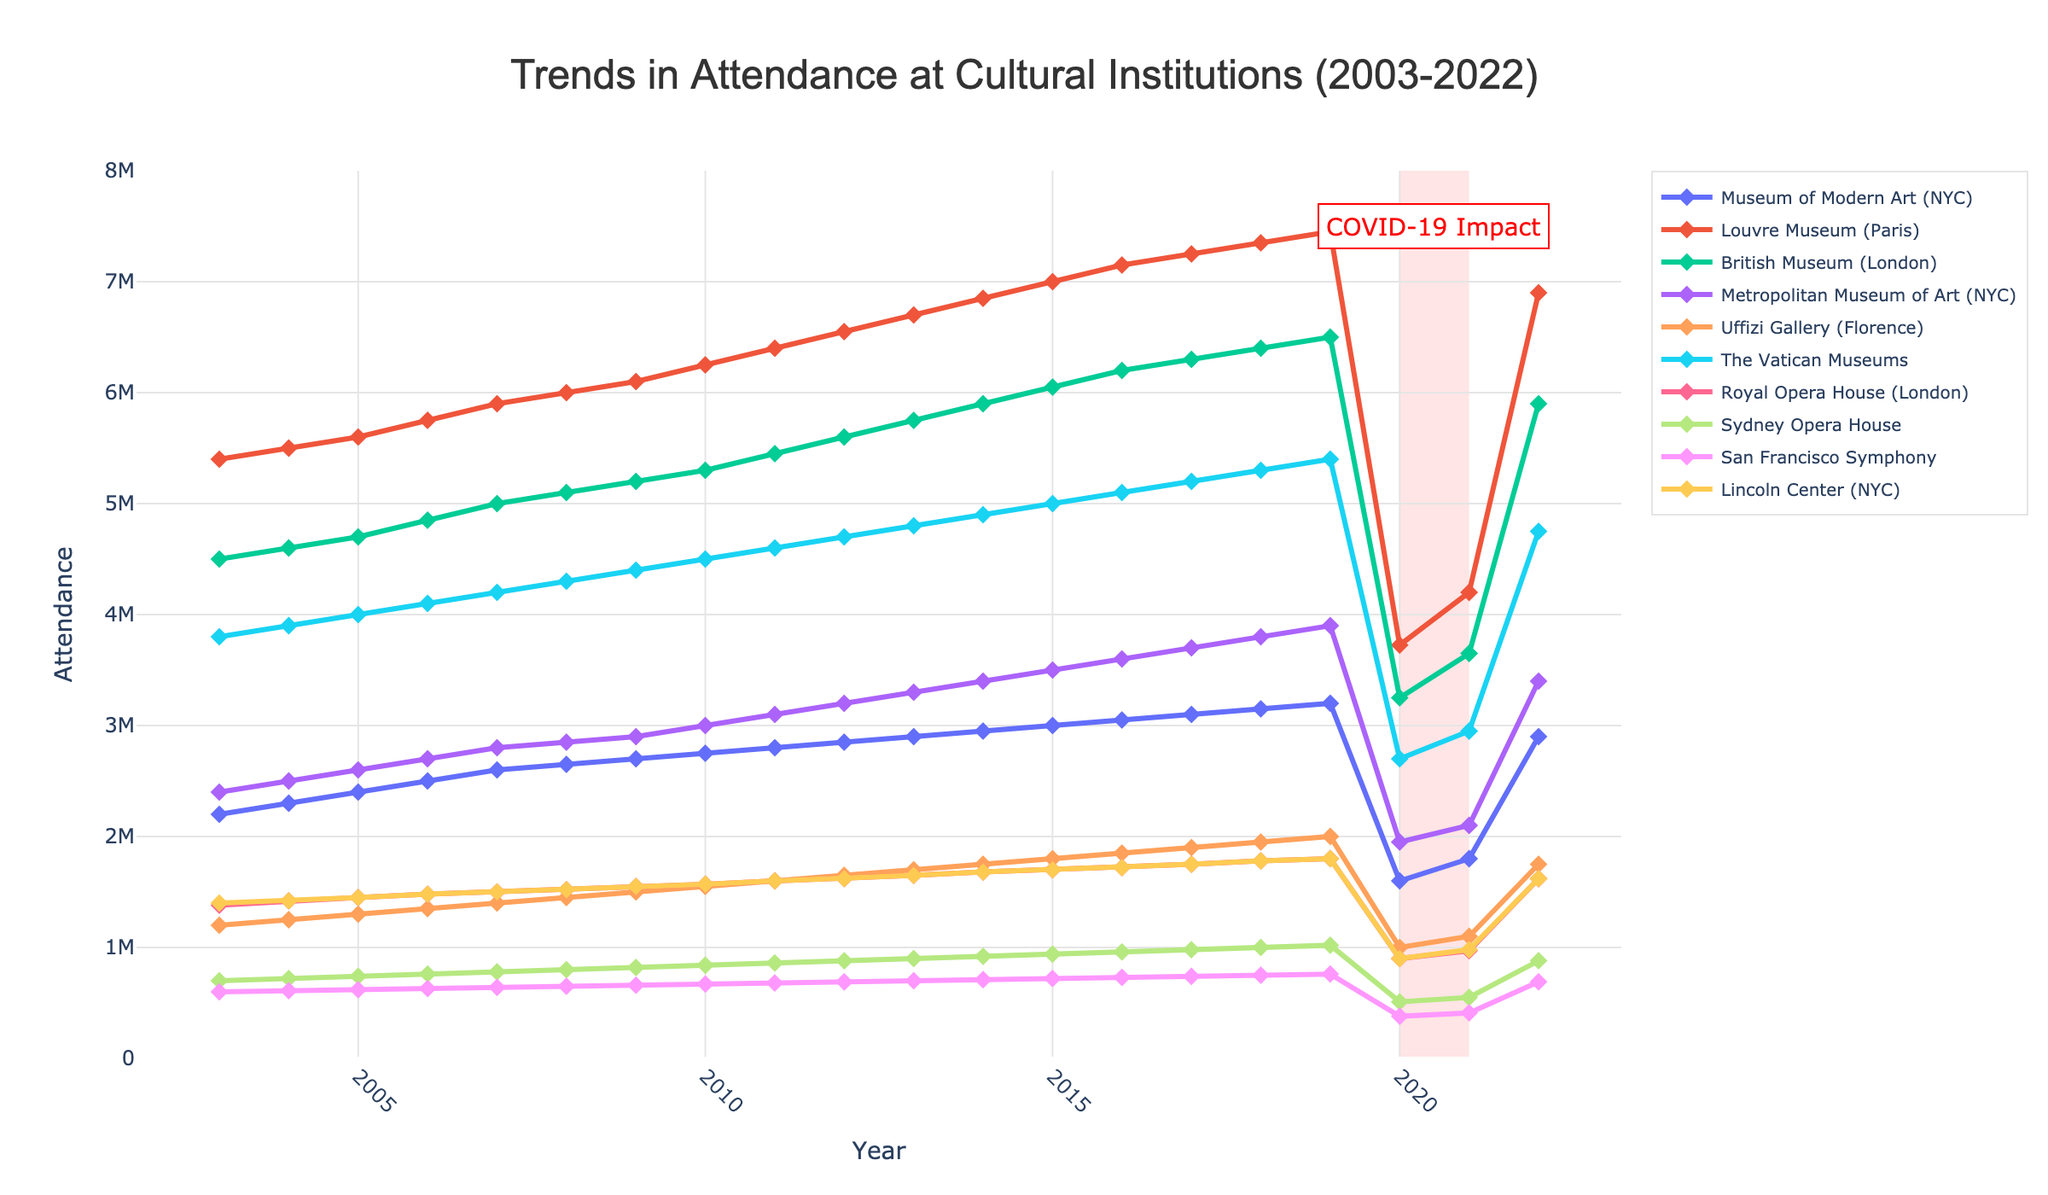What is the title of the figure? The title is usually located at the top of the figure and summarizes the main subject. According to the provided code, the title should be visible and clearly stated.
Answer: Trends in Attendance at Cultural Institutions (2003-2022) Which institution had the highest attendance in 2022? Look at the attendance values for all institutions in the year 2022 and identify the highest value. Comparing these values, the Louvre Museum (Paris) has the highest attendance.
Answer: Louvre Museum (Paris) What is the range of attendance for the Metropolitan Museum of Art (NYC) from 2003 to 2022? Identify the maximum and minimum attendance values for the Metropolitan Museum of Art (NYC) over the years 2003 to 2022. The maximum is 3900000 in 2019, and the minimum is 1950000 in 2020 due to COVID-19 impact.
Answer: 1950000 to 3900000 How did the attendance at the Sydney Opera House change during the COVID-19 period (2020-2021)? Look at the attendance values for the Sydney Opera House in the years 2020 and 2021. Determine if there was an increase, decrease, or no change. The attendance was 510000 in 2020 and 550000 in 2021.
Answer: It increased Between which years did the British Museum (London) see the largest increase in attendance? Calculate the year-to-year differences in attendance for the British Museum (London) from 2003 to 2022 and identify the largest increase. The largest increase is between 2021 (3650000) and 2022 (5900000).
Answer: 2021 to 2022 Comparing 2003 and 2022, which institution experienced the largest relative increase in attendance? Calculate the relative increase for each institution from 2003 to 2022 by finding the (attendance in 2022 - attendance in 2003)/attendance in 2003 and convert it to a percentage. The Louvre Museum (Paris) went from 5400000 to 6900000, an increase of ~27.8%.
Answer: Louvre Museum (Paris) During which years was there a noticeable impact of COVID-19 on attendance at these cultural institutions? Refer to the highlighted area on the plot for COVID-19 impact and check if the attendance values significantly dropped in those years. The highlighted years are 2020 and 2021 where there's a visible drop in attendance for all institutions.
Answer: 2020-2021 Which institution had the most consistent increase in attendance across the years? Observe the trends for all institutions from 2003 to 2022. Identify the one with the smoothest increase without significant drops or fluctuations. British Museum (London) shows a relatively consistent increase until COVID-19 impact.
Answer: British Museum (London) What was the attendance at Lincoln Center (NYC) in 2019 and how much did it decrease by 2020? Find the attendance for Lincoln Center (NYC) in 2019 and 2020 from the figure. The attendance was 1800000 in 2019 and 900000 in 2020. The decrease is 1800000 - 900000 = 900000.
Answer: 900000 (decrease of 900000) Did the San Francisco Symphony see an increase or decrease in attendance from 2003 to 2022? Compare the attendance values for San Francisco Symphony in 2003 and 2022. The attendance was 600000 in 2003 and 690000 in 2022.
Answer: Increase 